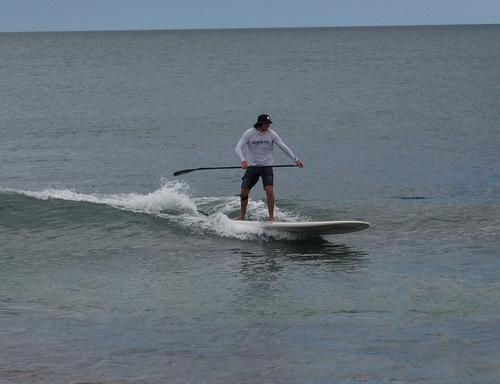How is the person maintaining balance on the surfboard, and what is the condition of the water? The person is holding a black paddle to maintain balance on the surfboard, while navigating the choppy waters. Briefly describe the scene captured in the image. The image shows a man paddleboarding on a white surfboard in the water with a blue sky in the background. Describe the setting of the image, including the weather. The setting is open water with a clear and blue sky, suggesting a sunny day. How is the man dressed and what is he holding? The man is wearing a white long sleeve shirt, black shorts, and a black cap, while holding a black paddle. State the main colors present in the image. The main colors are blue (sky and water), white (surfboard and shirt), and black (paddle, shorts, and hat). Are there any visible details on the man's shirt in the image? Yes, a word is visible on the man's shirt. What type of water body is the man paddleboarding on? The man is paddleboarding on open and choppy water. Identify the clothing items and accessories worn by the person in the image. The person is wearing a long sleeve white shirt, black shorts, and a black hat, with a word visible on his shirt. What color is the surfboard and what is the person doing on it? The surfboard is white and the person is paddleboarding on it. What can you infer about the man's clothing and accessories in terms of his chosen sport or activity? Judging by his clothing, the man is engaged in water sports, possibly paddleboarding or surfing, and is dressed for sun protection and mobility. 